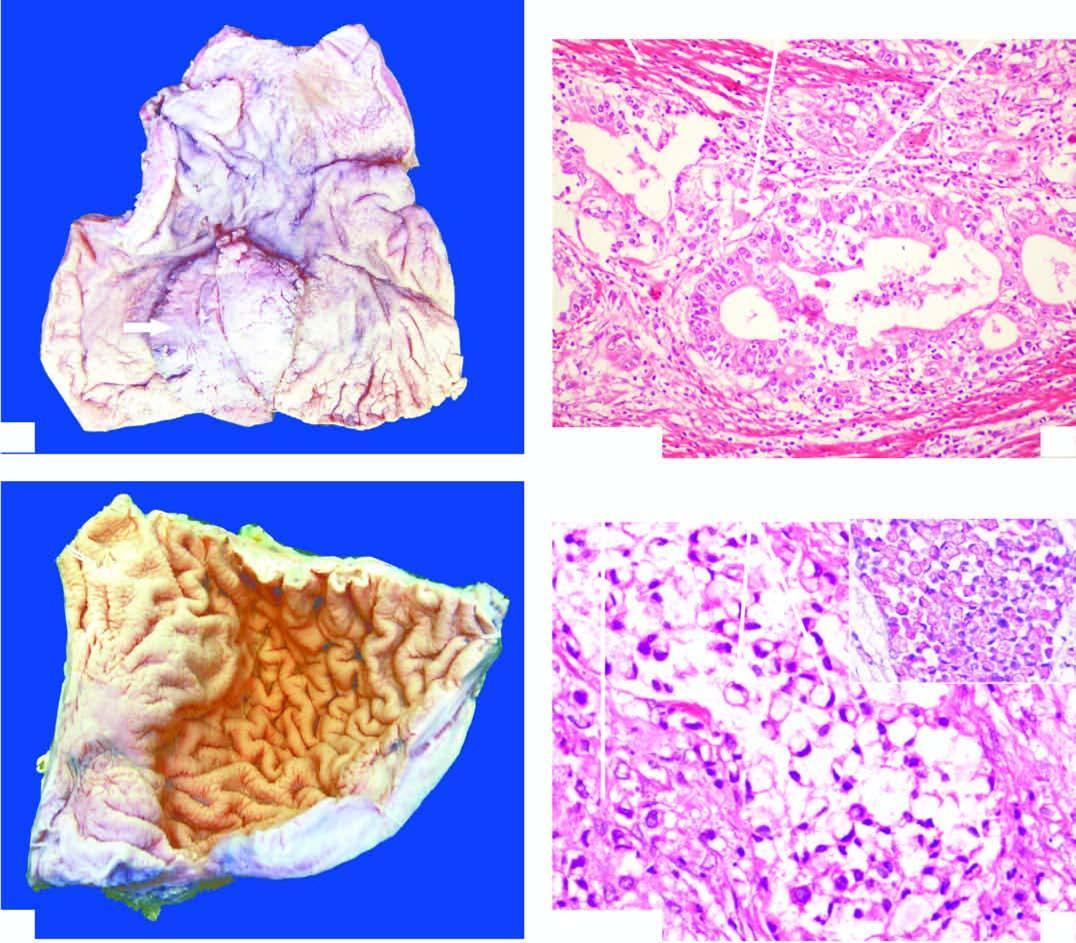does bone biopsy fold?
Answer the question using a single word or phrase. No 